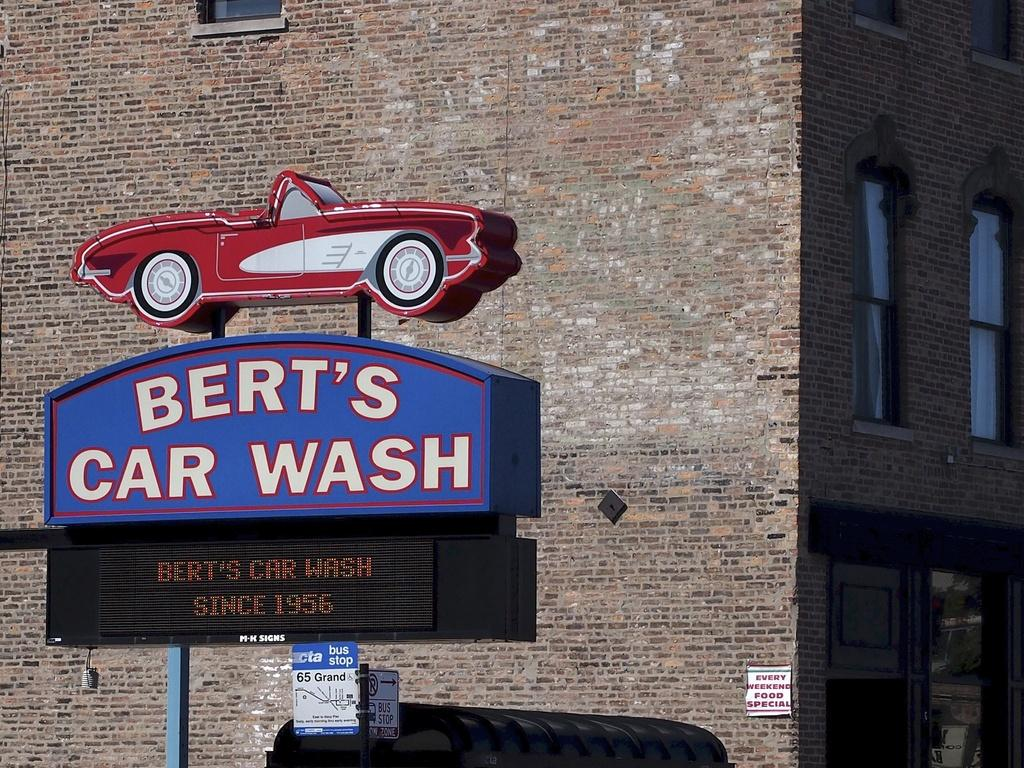What can be seen on the left side of the image? There are sign boards on the left side of the image. What is visible in the background of the image? There is a building in the background of the image. How many stars can be seen hanging from the sign boards in the image? There are no stars visible on the sign boards in the image. What type of organization is depicted on the sign boards in the image? The sign boards in the image do not depict any specific organization. 